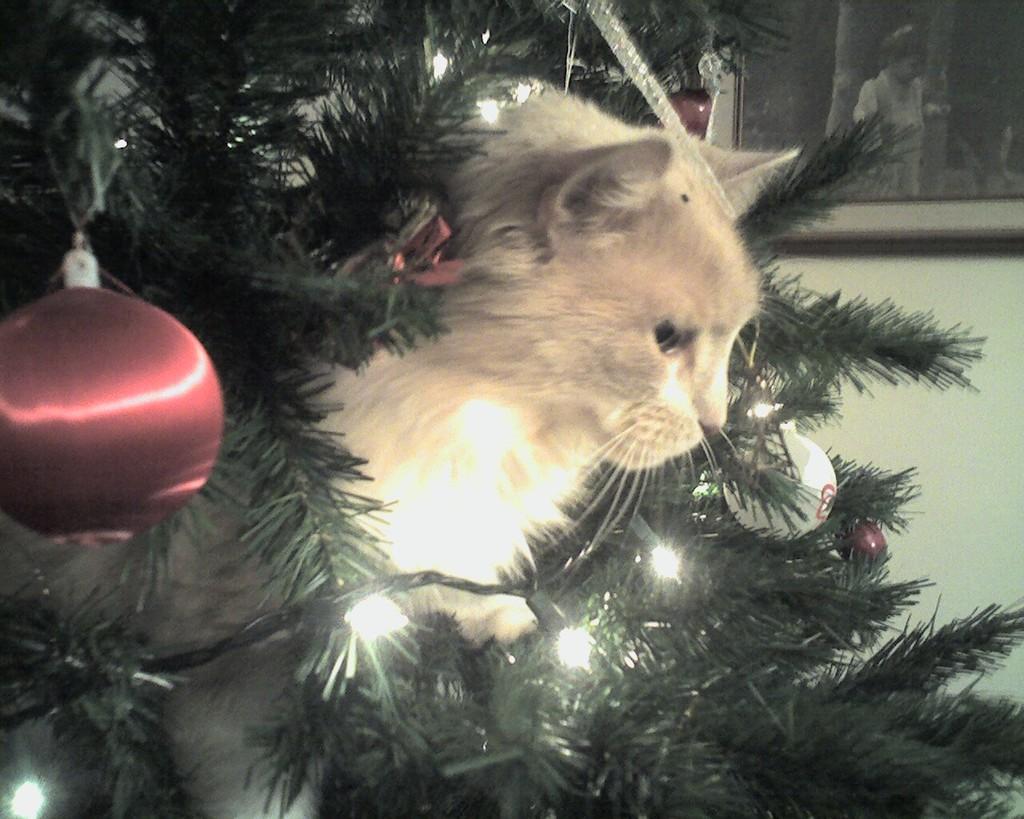In one or two sentences, can you explain what this image depicts? There is a Christmas tree and there is a cat in between the tree,there are beautiful lights arranged around the tree. 